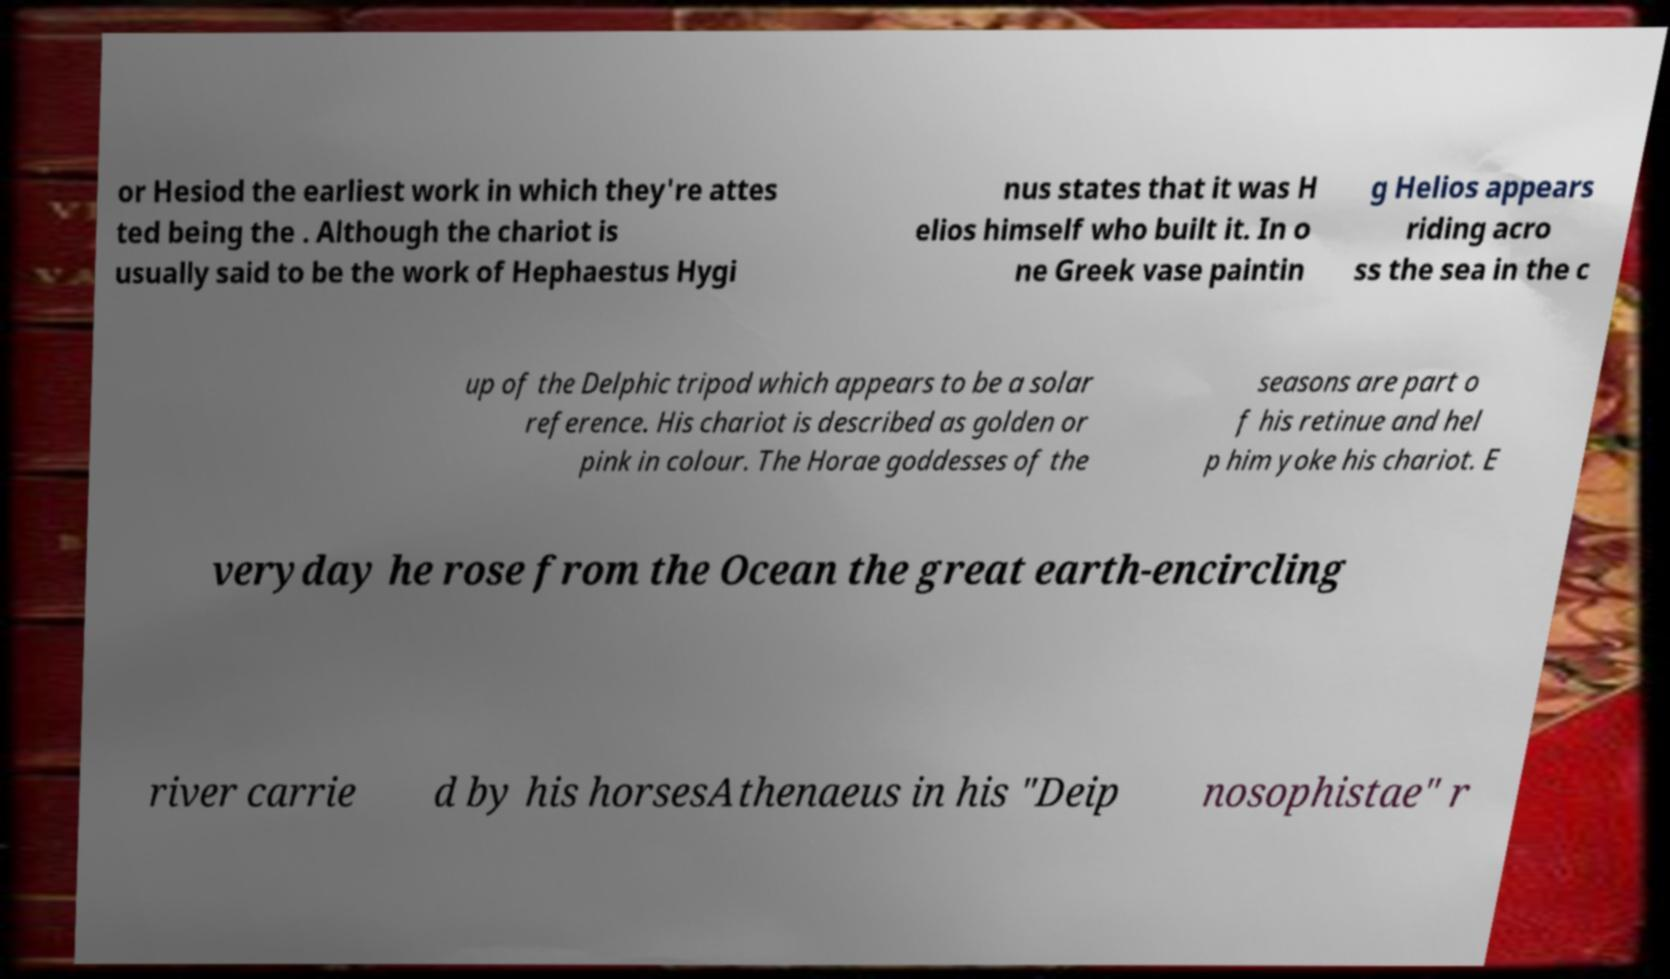Can you accurately transcribe the text from the provided image for me? or Hesiod the earliest work in which they're attes ted being the . Although the chariot is usually said to be the work of Hephaestus Hygi nus states that it was H elios himself who built it. In o ne Greek vase paintin g Helios appears riding acro ss the sea in the c up of the Delphic tripod which appears to be a solar reference. His chariot is described as golden or pink in colour. The Horae goddesses of the seasons are part o f his retinue and hel p him yoke his chariot. E veryday he rose from the Ocean the great earth-encircling river carrie d by his horsesAthenaeus in his "Deip nosophistae" r 